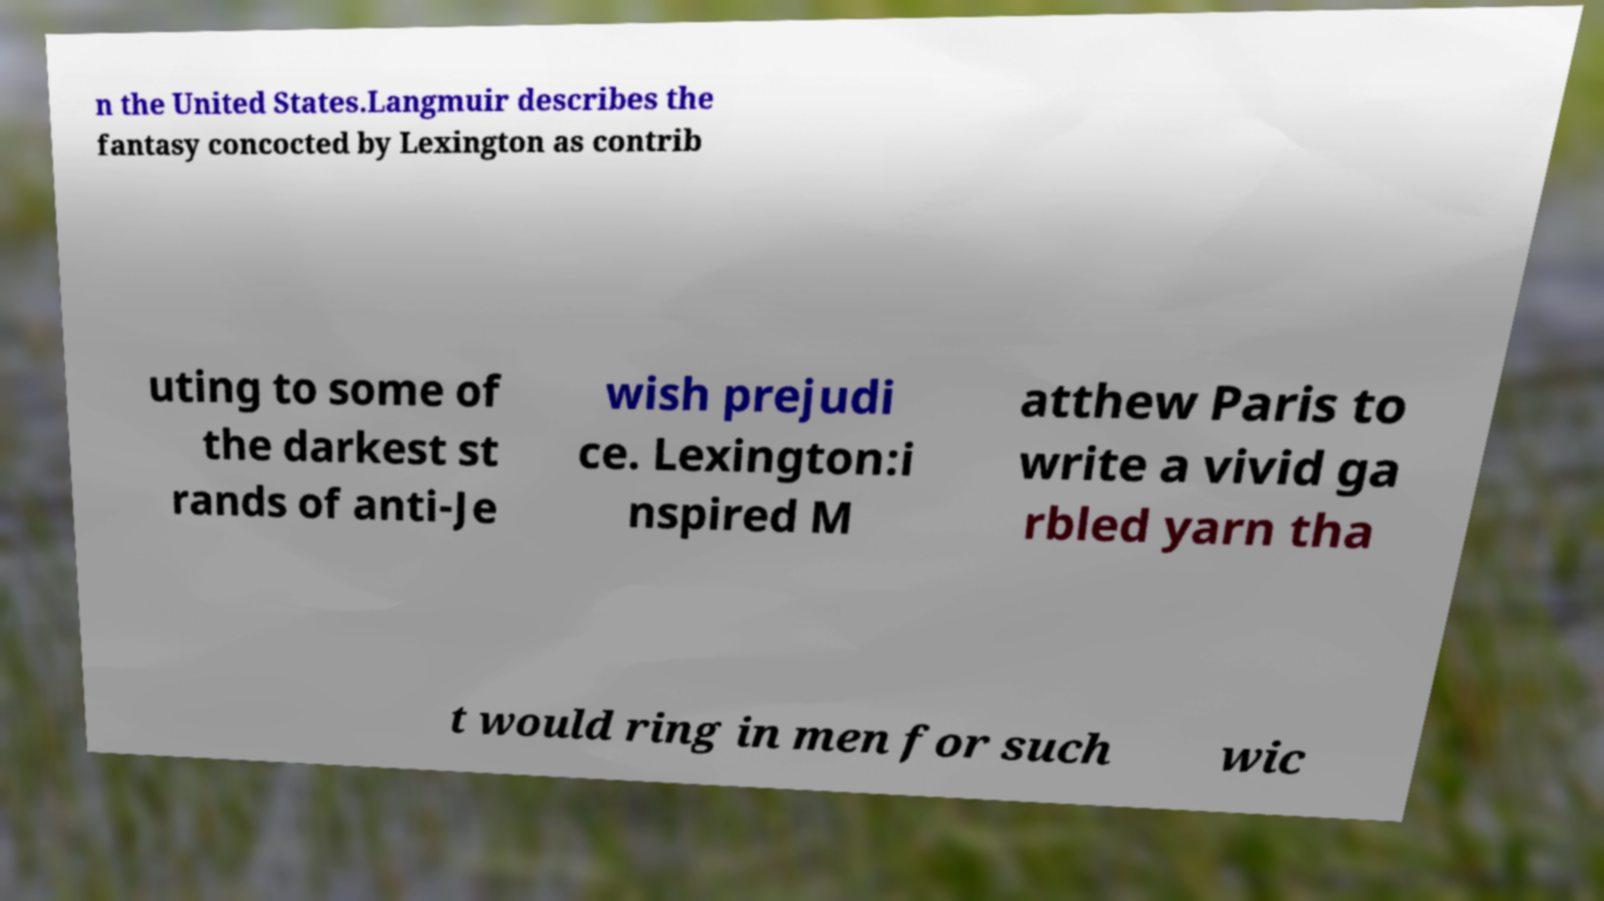Could you extract and type out the text from this image? n the United States.Langmuir describes the fantasy concocted by Lexington as contrib uting to some of the darkest st rands of anti-Je wish prejudi ce. Lexington:i nspired M atthew Paris to write a vivid ga rbled yarn tha t would ring in men for such wic 